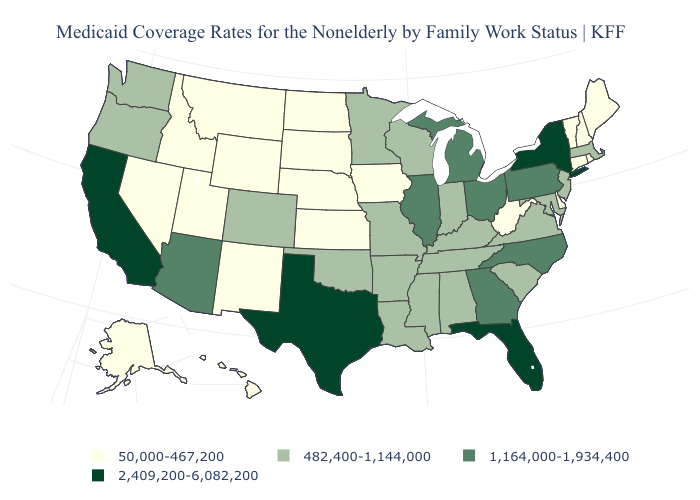Does Kentucky have a lower value than Georgia?
Quick response, please. Yes. Name the states that have a value in the range 2,409,200-6,082,200?
Answer briefly. California, Florida, New York, Texas. Does the first symbol in the legend represent the smallest category?
Answer briefly. Yes. Among the states that border New Hampshire , which have the lowest value?
Keep it brief. Maine, Vermont. What is the value of Colorado?
Quick response, please. 482,400-1,144,000. Name the states that have a value in the range 50,000-467,200?
Concise answer only. Alaska, Connecticut, Delaware, Hawaii, Idaho, Iowa, Kansas, Maine, Montana, Nebraska, Nevada, New Hampshire, New Mexico, North Dakota, Rhode Island, South Dakota, Utah, Vermont, West Virginia, Wyoming. Among the states that border Iowa , does South Dakota have the lowest value?
Keep it brief. Yes. Name the states that have a value in the range 1,164,000-1,934,400?
Be succinct. Arizona, Georgia, Illinois, Michigan, North Carolina, Ohio, Pennsylvania. Name the states that have a value in the range 2,409,200-6,082,200?
Write a very short answer. California, Florida, New York, Texas. What is the lowest value in the USA?
Answer briefly. 50,000-467,200. What is the value of Michigan?
Write a very short answer. 1,164,000-1,934,400. Among the states that border Vermont , does New Hampshire have the highest value?
Write a very short answer. No. What is the lowest value in states that border North Carolina?
Be succinct. 482,400-1,144,000. What is the value of Iowa?
Short answer required. 50,000-467,200. How many symbols are there in the legend?
Short answer required. 4. 